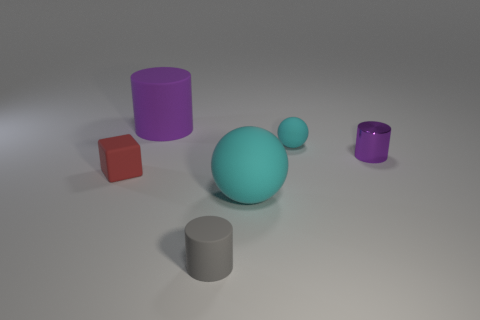Can you infer what the light source in the scene might be? Based on the shadows cast by the objects, the light source appears to come from above and to the left of the scene, suggesting a single light source such as a lamp or a similar artificial light.  What can you tell about the texture of the surface? The surface upon which the objects rest is matte and displays diffuse reflection, indicating it is likely not reflective or shiny. This kind of surface is common for highlighting the attributes of the objects placed upon it, without introducing distracting reflections. 